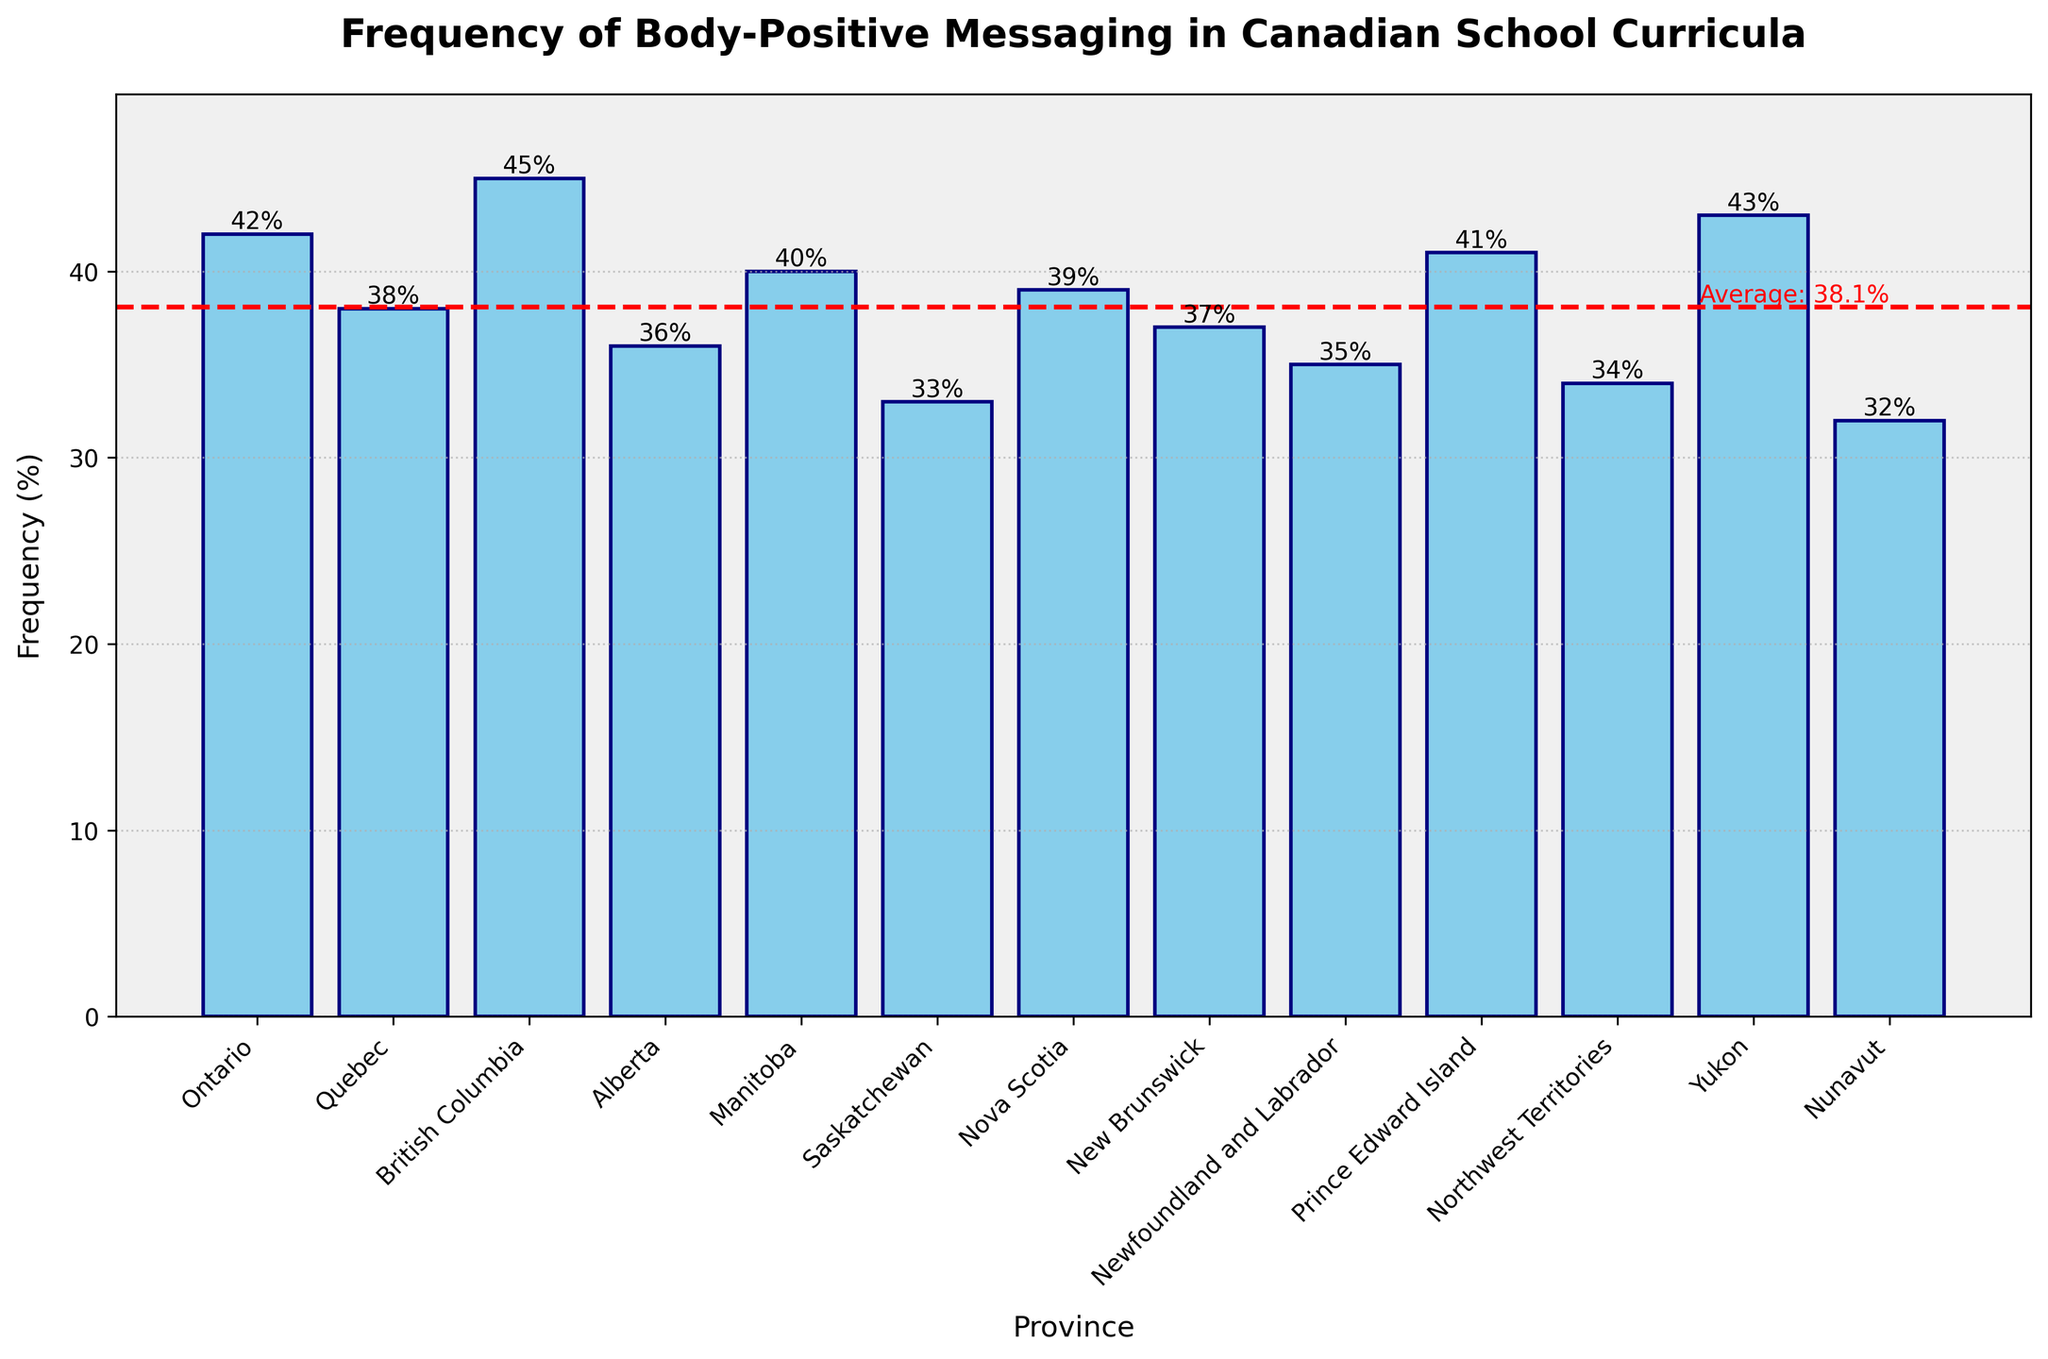What is the province with the highest frequency of body-positive messaging? Visually, the highest bar represents the province with the highest frequency of body-positive messaging. British Columbia has the highest bar at 45%.
Answer: British Columbia Which provinces have a frequency of body-positive messaging below 35%? Observing the bars, frequencies below 35% are represented by Nunavut (32%) and Saskatchewan (33%).
Answer: Nunavut, Saskatchewan What is the average frequency of body-positive messaging across all the provinces? The average is visually indicated by the dashed red line. The hover text shows the average as 37.5%.
Answer: 37.5% Which province has a body-positive messaging frequency equal to the average? 1. The average line intersects with only one bar. 
2. Upon review, New Brunswick's bar is at 37%, similar to the average value, confirming the data interpretation.
Answer: New Brunswick How much more frequently does Ontario discuss body-positive messaging compared to Northwest Territories? Ontario has a frequency of 42% and Northwest Territories has 34%. 42% (Ontario) - 34% (Northwest Territories) = 8% more.
Answer: 8% Is the body-positive messaging frequency in Prince Edward Island above or below the average? Visually comparing Prince Edward Island's bar at 41% with the average line at 37.5%, it is above the average.
Answer: Above How many provinces have a higher frequency than the average? By counting the bars above the average line: Ontario, British Columbia, Manitoba, Nova Scotia, Prince Edward Island, and Yukon, 6 provinces in total surpass the average.
Answer: 6 What is the frequency of body-positive messaging in Alberta? By checking the height of Alberta’s bar, the label shows 36%.
Answer: 36% By how many percentage points does British Columbia exceed Nunavut in frequency? British Columbia has 45%, and Nunavut has 32%. The difference is 45% - 32% = 13%.
Answer: 13% Which province has the second-highest frequency of body-positive messaging? The second-highest bar after British Columbia (45%) is Yukon at 43%.
Answer: Yukon 